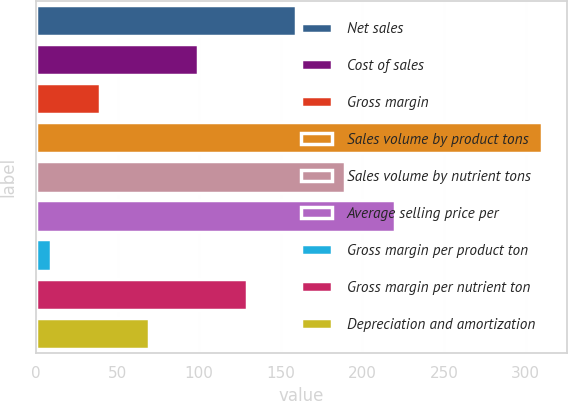Convert chart to OTSL. <chart><loc_0><loc_0><loc_500><loc_500><bar_chart><fcel>Net sales<fcel>Cost of sales<fcel>Gross margin<fcel>Sales volume by product tons<fcel>Sales volume by nutrient tons<fcel>Average selling price per<fcel>Gross margin per product ton<fcel>Gross margin per nutrient ton<fcel>Depreciation and amortization<nl><fcel>159.5<fcel>99.3<fcel>39.1<fcel>310<fcel>189.6<fcel>219.7<fcel>9<fcel>129.4<fcel>69.2<nl></chart> 